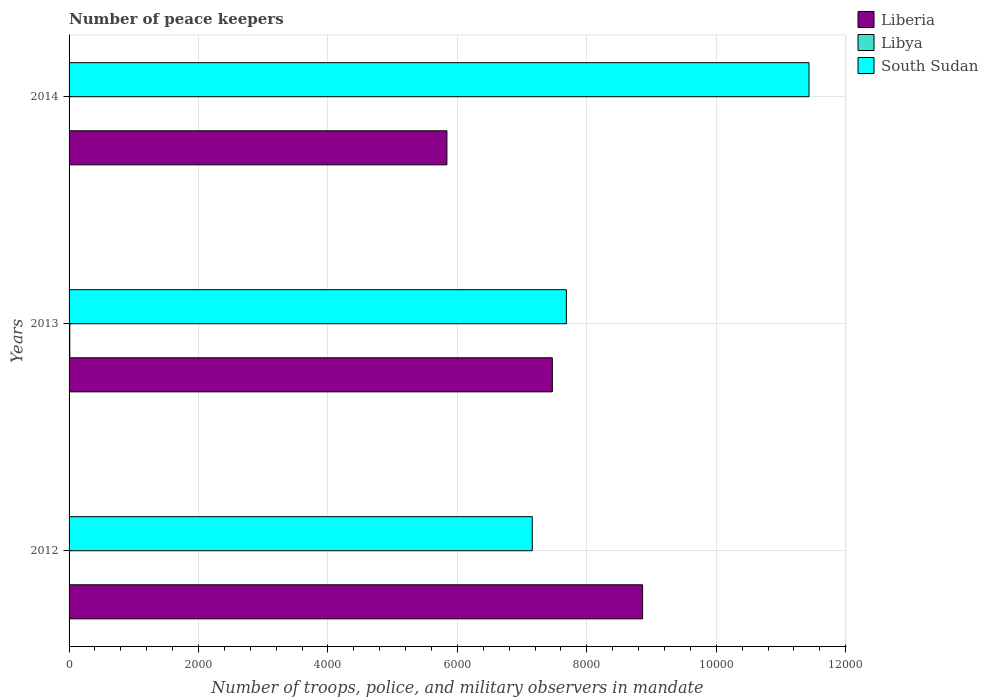How many different coloured bars are there?
Your answer should be compact. 3. How many groups of bars are there?
Your answer should be compact. 3. Are the number of bars on each tick of the Y-axis equal?
Give a very brief answer. Yes. How many bars are there on the 1st tick from the top?
Provide a succinct answer. 3. What is the label of the 1st group of bars from the top?
Your answer should be very brief. 2014. In how many cases, is the number of bars for a given year not equal to the number of legend labels?
Offer a terse response. 0. What is the number of peace keepers in in Liberia in 2013?
Provide a succinct answer. 7467. Across all years, what is the maximum number of peace keepers in in South Sudan?
Keep it short and to the point. 1.14e+04. Across all years, what is the minimum number of peace keepers in in South Sudan?
Provide a succinct answer. 7157. What is the total number of peace keepers in in Liberia in the graph?
Your answer should be compact. 2.22e+04. What is the difference between the number of peace keepers in in Liberia in 2013 and that in 2014?
Give a very brief answer. 1629. What is the difference between the number of peace keepers in in Libya in 2014 and the number of peace keepers in in Liberia in 2012?
Offer a terse response. -8860. What is the average number of peace keepers in in Liberia per year?
Offer a very short reply. 7389. In the year 2013, what is the difference between the number of peace keepers in in Liberia and number of peace keepers in in South Sudan?
Your answer should be very brief. -217. What is the ratio of the number of peace keepers in in Liberia in 2013 to that in 2014?
Offer a very short reply. 1.28. Is the difference between the number of peace keepers in in Liberia in 2013 and 2014 greater than the difference between the number of peace keepers in in South Sudan in 2013 and 2014?
Offer a terse response. Yes. What is the difference between the highest and the second highest number of peace keepers in in South Sudan?
Your answer should be compact. 3749. What is the difference between the highest and the lowest number of peace keepers in in Libya?
Your answer should be very brief. 9. Is the sum of the number of peace keepers in in South Sudan in 2012 and 2014 greater than the maximum number of peace keepers in in Liberia across all years?
Ensure brevity in your answer.  Yes. What does the 2nd bar from the top in 2013 represents?
Give a very brief answer. Libya. What does the 1st bar from the bottom in 2013 represents?
Provide a short and direct response. Liberia. What is the difference between two consecutive major ticks on the X-axis?
Your answer should be compact. 2000. Does the graph contain any zero values?
Your answer should be compact. No. How many legend labels are there?
Offer a very short reply. 3. How are the legend labels stacked?
Offer a terse response. Vertical. What is the title of the graph?
Ensure brevity in your answer.  Number of peace keepers. What is the label or title of the X-axis?
Provide a succinct answer. Number of troops, police, and military observers in mandate. What is the label or title of the Y-axis?
Provide a succinct answer. Years. What is the Number of troops, police, and military observers in mandate of Liberia in 2012?
Provide a short and direct response. 8862. What is the Number of troops, police, and military observers in mandate in Libya in 2012?
Your answer should be very brief. 2. What is the Number of troops, police, and military observers in mandate of South Sudan in 2012?
Offer a terse response. 7157. What is the Number of troops, police, and military observers in mandate in Liberia in 2013?
Your answer should be very brief. 7467. What is the Number of troops, police, and military observers in mandate in South Sudan in 2013?
Keep it short and to the point. 7684. What is the Number of troops, police, and military observers in mandate of Liberia in 2014?
Provide a succinct answer. 5838. What is the Number of troops, police, and military observers in mandate of Libya in 2014?
Keep it short and to the point. 2. What is the Number of troops, police, and military observers in mandate of South Sudan in 2014?
Your answer should be compact. 1.14e+04. Across all years, what is the maximum Number of troops, police, and military observers in mandate in Liberia?
Make the answer very short. 8862. Across all years, what is the maximum Number of troops, police, and military observers in mandate of South Sudan?
Offer a terse response. 1.14e+04. Across all years, what is the minimum Number of troops, police, and military observers in mandate of Liberia?
Offer a very short reply. 5838. Across all years, what is the minimum Number of troops, police, and military observers in mandate of Libya?
Give a very brief answer. 2. Across all years, what is the minimum Number of troops, police, and military observers in mandate in South Sudan?
Keep it short and to the point. 7157. What is the total Number of troops, police, and military observers in mandate in Liberia in the graph?
Provide a succinct answer. 2.22e+04. What is the total Number of troops, police, and military observers in mandate of South Sudan in the graph?
Offer a very short reply. 2.63e+04. What is the difference between the Number of troops, police, and military observers in mandate of Liberia in 2012 and that in 2013?
Your answer should be very brief. 1395. What is the difference between the Number of troops, police, and military observers in mandate in Libya in 2012 and that in 2013?
Make the answer very short. -9. What is the difference between the Number of troops, police, and military observers in mandate in South Sudan in 2012 and that in 2013?
Your response must be concise. -527. What is the difference between the Number of troops, police, and military observers in mandate of Liberia in 2012 and that in 2014?
Your answer should be compact. 3024. What is the difference between the Number of troops, police, and military observers in mandate in South Sudan in 2012 and that in 2014?
Give a very brief answer. -4276. What is the difference between the Number of troops, police, and military observers in mandate of Liberia in 2013 and that in 2014?
Your response must be concise. 1629. What is the difference between the Number of troops, police, and military observers in mandate in Libya in 2013 and that in 2014?
Keep it short and to the point. 9. What is the difference between the Number of troops, police, and military observers in mandate of South Sudan in 2013 and that in 2014?
Keep it short and to the point. -3749. What is the difference between the Number of troops, police, and military observers in mandate in Liberia in 2012 and the Number of troops, police, and military observers in mandate in Libya in 2013?
Give a very brief answer. 8851. What is the difference between the Number of troops, police, and military observers in mandate in Liberia in 2012 and the Number of troops, police, and military observers in mandate in South Sudan in 2013?
Ensure brevity in your answer.  1178. What is the difference between the Number of troops, police, and military observers in mandate of Libya in 2012 and the Number of troops, police, and military observers in mandate of South Sudan in 2013?
Your response must be concise. -7682. What is the difference between the Number of troops, police, and military observers in mandate of Liberia in 2012 and the Number of troops, police, and military observers in mandate of Libya in 2014?
Your answer should be compact. 8860. What is the difference between the Number of troops, police, and military observers in mandate in Liberia in 2012 and the Number of troops, police, and military observers in mandate in South Sudan in 2014?
Offer a very short reply. -2571. What is the difference between the Number of troops, police, and military observers in mandate in Libya in 2012 and the Number of troops, police, and military observers in mandate in South Sudan in 2014?
Ensure brevity in your answer.  -1.14e+04. What is the difference between the Number of troops, police, and military observers in mandate of Liberia in 2013 and the Number of troops, police, and military observers in mandate of Libya in 2014?
Your response must be concise. 7465. What is the difference between the Number of troops, police, and military observers in mandate in Liberia in 2013 and the Number of troops, police, and military observers in mandate in South Sudan in 2014?
Give a very brief answer. -3966. What is the difference between the Number of troops, police, and military observers in mandate in Libya in 2013 and the Number of troops, police, and military observers in mandate in South Sudan in 2014?
Offer a very short reply. -1.14e+04. What is the average Number of troops, police, and military observers in mandate in Liberia per year?
Provide a succinct answer. 7389. What is the average Number of troops, police, and military observers in mandate of Libya per year?
Keep it short and to the point. 5. What is the average Number of troops, police, and military observers in mandate in South Sudan per year?
Offer a terse response. 8758. In the year 2012, what is the difference between the Number of troops, police, and military observers in mandate in Liberia and Number of troops, police, and military observers in mandate in Libya?
Your answer should be compact. 8860. In the year 2012, what is the difference between the Number of troops, police, and military observers in mandate of Liberia and Number of troops, police, and military observers in mandate of South Sudan?
Your response must be concise. 1705. In the year 2012, what is the difference between the Number of troops, police, and military observers in mandate of Libya and Number of troops, police, and military observers in mandate of South Sudan?
Make the answer very short. -7155. In the year 2013, what is the difference between the Number of troops, police, and military observers in mandate in Liberia and Number of troops, police, and military observers in mandate in Libya?
Ensure brevity in your answer.  7456. In the year 2013, what is the difference between the Number of troops, police, and military observers in mandate in Liberia and Number of troops, police, and military observers in mandate in South Sudan?
Offer a very short reply. -217. In the year 2013, what is the difference between the Number of troops, police, and military observers in mandate of Libya and Number of troops, police, and military observers in mandate of South Sudan?
Make the answer very short. -7673. In the year 2014, what is the difference between the Number of troops, police, and military observers in mandate of Liberia and Number of troops, police, and military observers in mandate of Libya?
Offer a very short reply. 5836. In the year 2014, what is the difference between the Number of troops, police, and military observers in mandate in Liberia and Number of troops, police, and military observers in mandate in South Sudan?
Your response must be concise. -5595. In the year 2014, what is the difference between the Number of troops, police, and military observers in mandate of Libya and Number of troops, police, and military observers in mandate of South Sudan?
Provide a short and direct response. -1.14e+04. What is the ratio of the Number of troops, police, and military observers in mandate in Liberia in 2012 to that in 2013?
Your response must be concise. 1.19. What is the ratio of the Number of troops, police, and military observers in mandate in Libya in 2012 to that in 2013?
Ensure brevity in your answer.  0.18. What is the ratio of the Number of troops, police, and military observers in mandate of South Sudan in 2012 to that in 2013?
Provide a short and direct response. 0.93. What is the ratio of the Number of troops, police, and military observers in mandate of Liberia in 2012 to that in 2014?
Your answer should be very brief. 1.52. What is the ratio of the Number of troops, police, and military observers in mandate in South Sudan in 2012 to that in 2014?
Your response must be concise. 0.63. What is the ratio of the Number of troops, police, and military observers in mandate in Liberia in 2013 to that in 2014?
Your answer should be compact. 1.28. What is the ratio of the Number of troops, police, and military observers in mandate in South Sudan in 2013 to that in 2014?
Keep it short and to the point. 0.67. What is the difference between the highest and the second highest Number of troops, police, and military observers in mandate in Liberia?
Offer a terse response. 1395. What is the difference between the highest and the second highest Number of troops, police, and military observers in mandate of South Sudan?
Make the answer very short. 3749. What is the difference between the highest and the lowest Number of troops, police, and military observers in mandate in Liberia?
Give a very brief answer. 3024. What is the difference between the highest and the lowest Number of troops, police, and military observers in mandate of South Sudan?
Keep it short and to the point. 4276. 